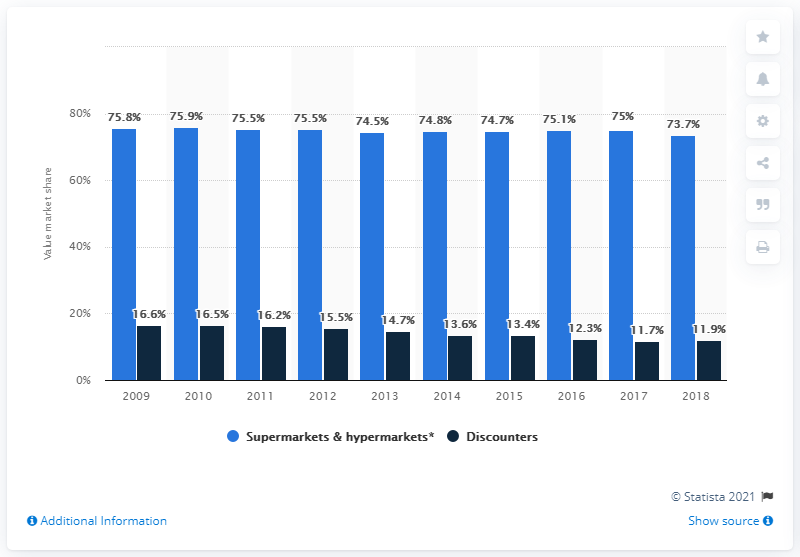Specify some key components in this picture. According to data from 2014, the market value share of canned fish and seafood in France was approximately 75%. 